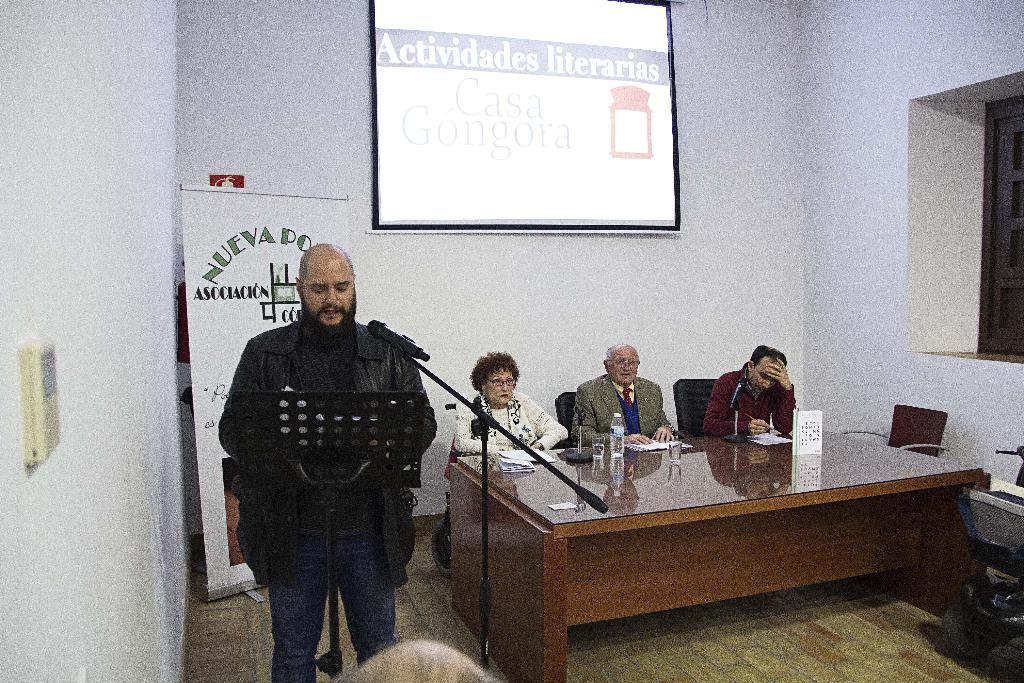How many people are present in the image? There are four people in the image. What is one person doing in the image? One person is standing in front of a mic. What can be seen in the background of the image? There is a banner in the background. What is being projected onto a wall in the image? There is a projector projecting onto a wall. What type of gun is being used by one of the people in the image? There is no gun present in the image; it features four people, one standing in front of a mic, a banner in the background, and a projector projecting onto a wall. How much rice is being served to the people in the image? There is no mention of rice or any food in the image; it focuses on the people, the mic, the banner, and the projector. 